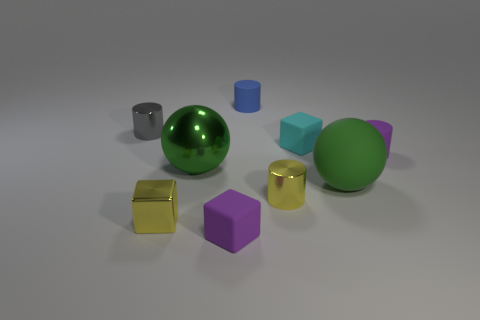Add 1 small yellow blocks. How many objects exist? 10 Subtract all small yellow cylinders. How many cylinders are left? 3 Subtract 1 cylinders. How many cylinders are left? 3 Subtract all purple cylinders. How many cylinders are left? 3 Subtract all cylinders. How many objects are left? 5 Subtract 1 purple blocks. How many objects are left? 8 Subtract all cyan cylinders. Subtract all blue spheres. How many cylinders are left? 4 Subtract all tiny cyan things. Subtract all small purple rubber cubes. How many objects are left? 7 Add 1 metal blocks. How many metal blocks are left? 2 Add 3 tiny green matte cubes. How many tiny green matte cubes exist? 3 